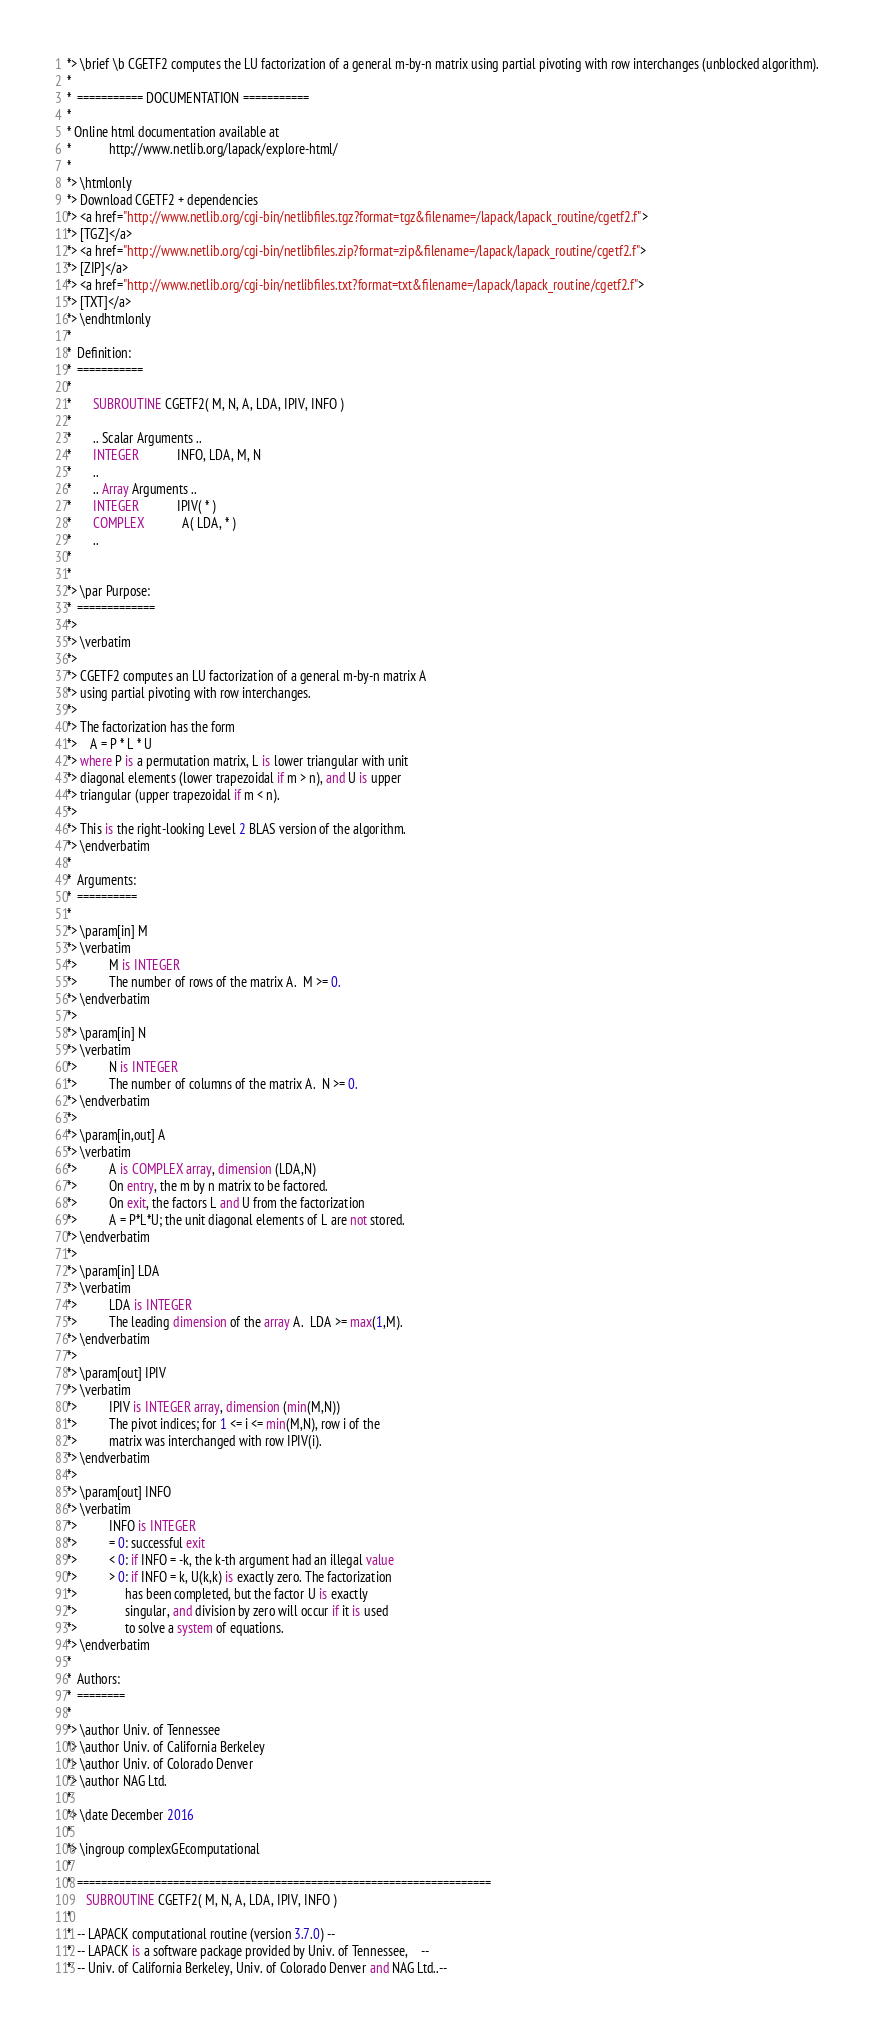<code> <loc_0><loc_0><loc_500><loc_500><_FORTRAN_>*> \brief \b CGETF2 computes the LU factorization of a general m-by-n matrix using partial pivoting with row interchanges (unblocked algorithm).
*
*  =========== DOCUMENTATION ===========
*
* Online html documentation available at
*            http://www.netlib.org/lapack/explore-html/
*
*> \htmlonly
*> Download CGETF2 + dependencies
*> <a href="http://www.netlib.org/cgi-bin/netlibfiles.tgz?format=tgz&filename=/lapack/lapack_routine/cgetf2.f">
*> [TGZ]</a>
*> <a href="http://www.netlib.org/cgi-bin/netlibfiles.zip?format=zip&filename=/lapack/lapack_routine/cgetf2.f">
*> [ZIP]</a>
*> <a href="http://www.netlib.org/cgi-bin/netlibfiles.txt?format=txt&filename=/lapack/lapack_routine/cgetf2.f">
*> [TXT]</a>
*> \endhtmlonly
*
*  Definition:
*  ===========
*
*       SUBROUTINE CGETF2( M, N, A, LDA, IPIV, INFO )
*
*       .. Scalar Arguments ..
*       INTEGER            INFO, LDA, M, N
*       ..
*       .. Array Arguments ..
*       INTEGER            IPIV( * )
*       COMPLEX            A( LDA, * )
*       ..
*
*
*> \par Purpose:
*  =============
*>
*> \verbatim
*>
*> CGETF2 computes an LU factorization of a general m-by-n matrix A
*> using partial pivoting with row interchanges.
*>
*> The factorization has the form
*>    A = P * L * U
*> where P is a permutation matrix, L is lower triangular with unit
*> diagonal elements (lower trapezoidal if m > n), and U is upper
*> triangular (upper trapezoidal if m < n).
*>
*> This is the right-looking Level 2 BLAS version of the algorithm.
*> \endverbatim
*
*  Arguments:
*  ==========
*
*> \param[in] M
*> \verbatim
*>          M is INTEGER
*>          The number of rows of the matrix A.  M >= 0.
*> \endverbatim
*>
*> \param[in] N
*> \verbatim
*>          N is INTEGER
*>          The number of columns of the matrix A.  N >= 0.
*> \endverbatim
*>
*> \param[in,out] A
*> \verbatim
*>          A is COMPLEX array, dimension (LDA,N)
*>          On entry, the m by n matrix to be factored.
*>          On exit, the factors L and U from the factorization
*>          A = P*L*U; the unit diagonal elements of L are not stored.
*> \endverbatim
*>
*> \param[in] LDA
*> \verbatim
*>          LDA is INTEGER
*>          The leading dimension of the array A.  LDA >= max(1,M).
*> \endverbatim
*>
*> \param[out] IPIV
*> \verbatim
*>          IPIV is INTEGER array, dimension (min(M,N))
*>          The pivot indices; for 1 <= i <= min(M,N), row i of the
*>          matrix was interchanged with row IPIV(i).
*> \endverbatim
*>
*> \param[out] INFO
*> \verbatim
*>          INFO is INTEGER
*>          = 0: successful exit
*>          < 0: if INFO = -k, the k-th argument had an illegal value
*>          > 0: if INFO = k, U(k,k) is exactly zero. The factorization
*>               has been completed, but the factor U is exactly
*>               singular, and division by zero will occur if it is used
*>               to solve a system of equations.
*> \endverbatim
*
*  Authors:
*  ========
*
*> \author Univ. of Tennessee
*> \author Univ. of California Berkeley
*> \author Univ. of Colorado Denver
*> \author NAG Ltd.
*
*> \date December 2016
*
*> \ingroup complexGEcomputational
*
*  =====================================================================
      SUBROUTINE CGETF2( M, N, A, LDA, IPIV, INFO )
*
*  -- LAPACK computational routine (version 3.7.0) --
*  -- LAPACK is a software package provided by Univ. of Tennessee,    --
*  -- Univ. of California Berkeley, Univ. of Colorado Denver and NAG Ltd..--</code> 